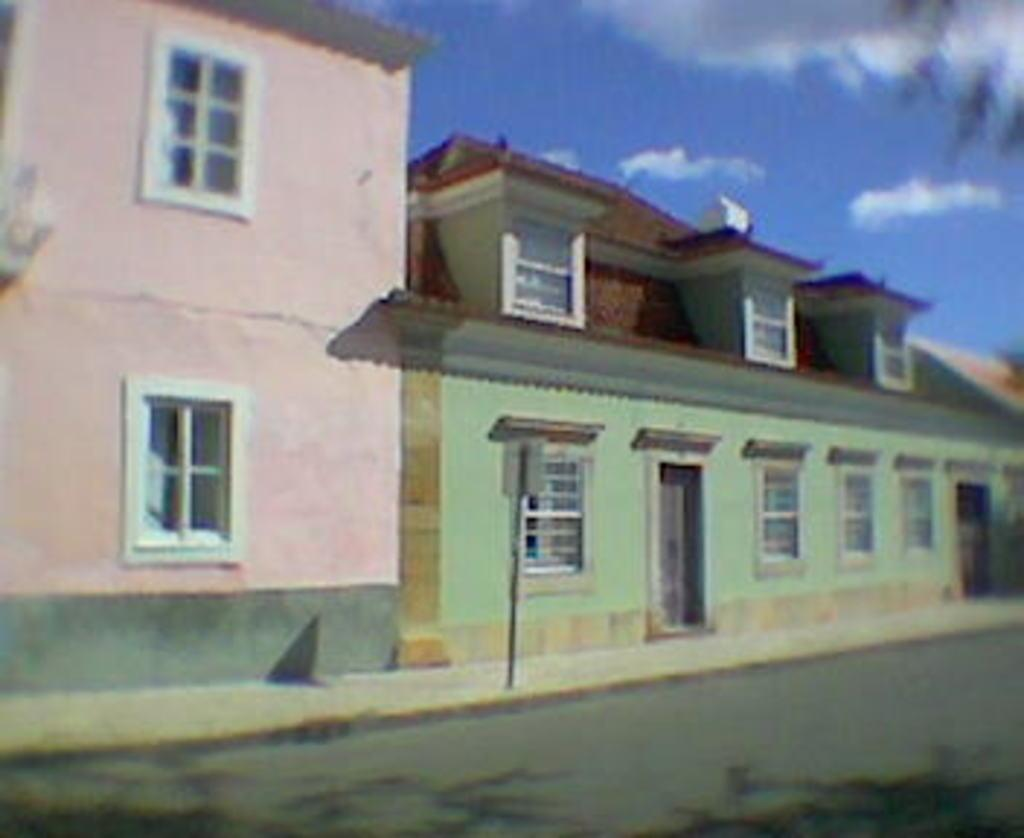What type of structure is present in the image? There is a house in the image. What features can be seen on the house? The house has windows and doors. What is located at the bottom of the image? There is a road at the bottom of the image. What is visible at the top of the image? The sky is visible at the top of the image. What can be observed in the sky? There are clouds in the sky. Where is the throne located in the image? There is no throne present in the image. Is the fan visible in the image? There is no fan present in the image. 